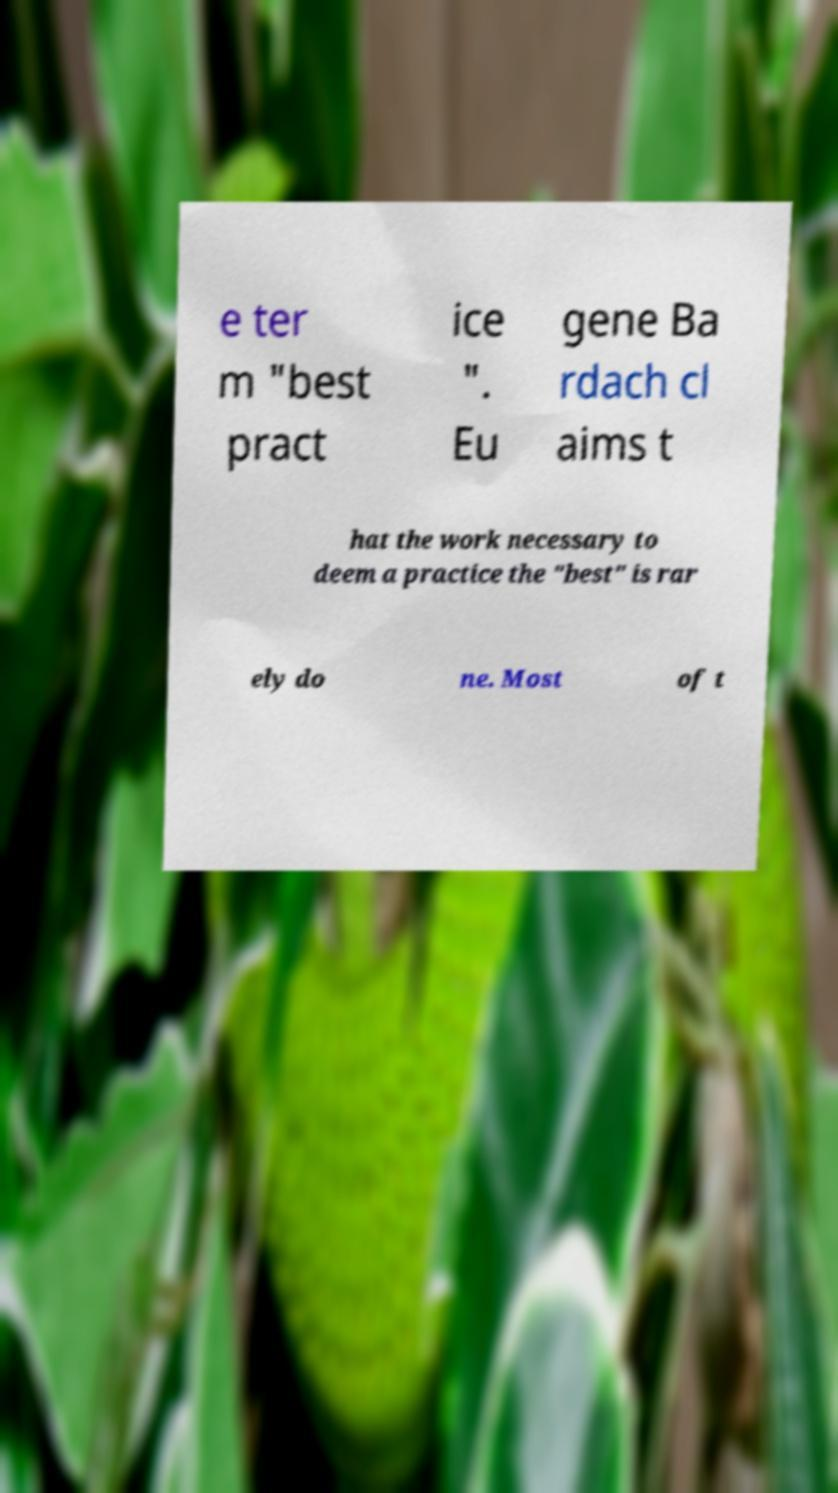Can you accurately transcribe the text from the provided image for me? e ter m "best pract ice ". Eu gene Ba rdach cl aims t hat the work necessary to deem a practice the "best" is rar ely do ne. Most of t 